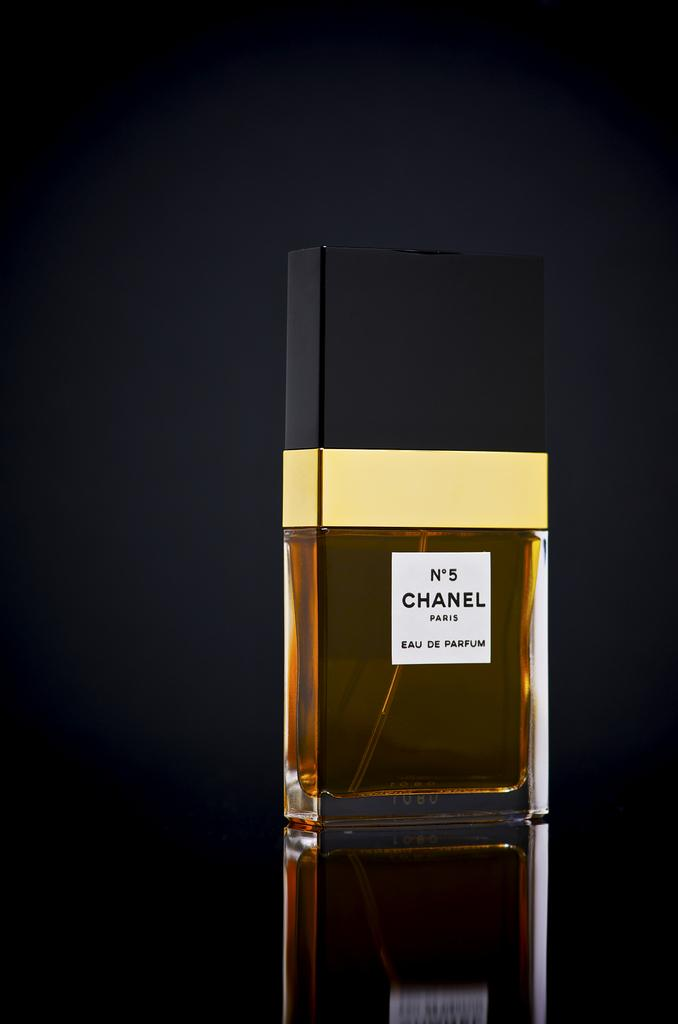<image>
Relay a brief, clear account of the picture shown. A bottle of Chanel perfume against a black backdrop. 